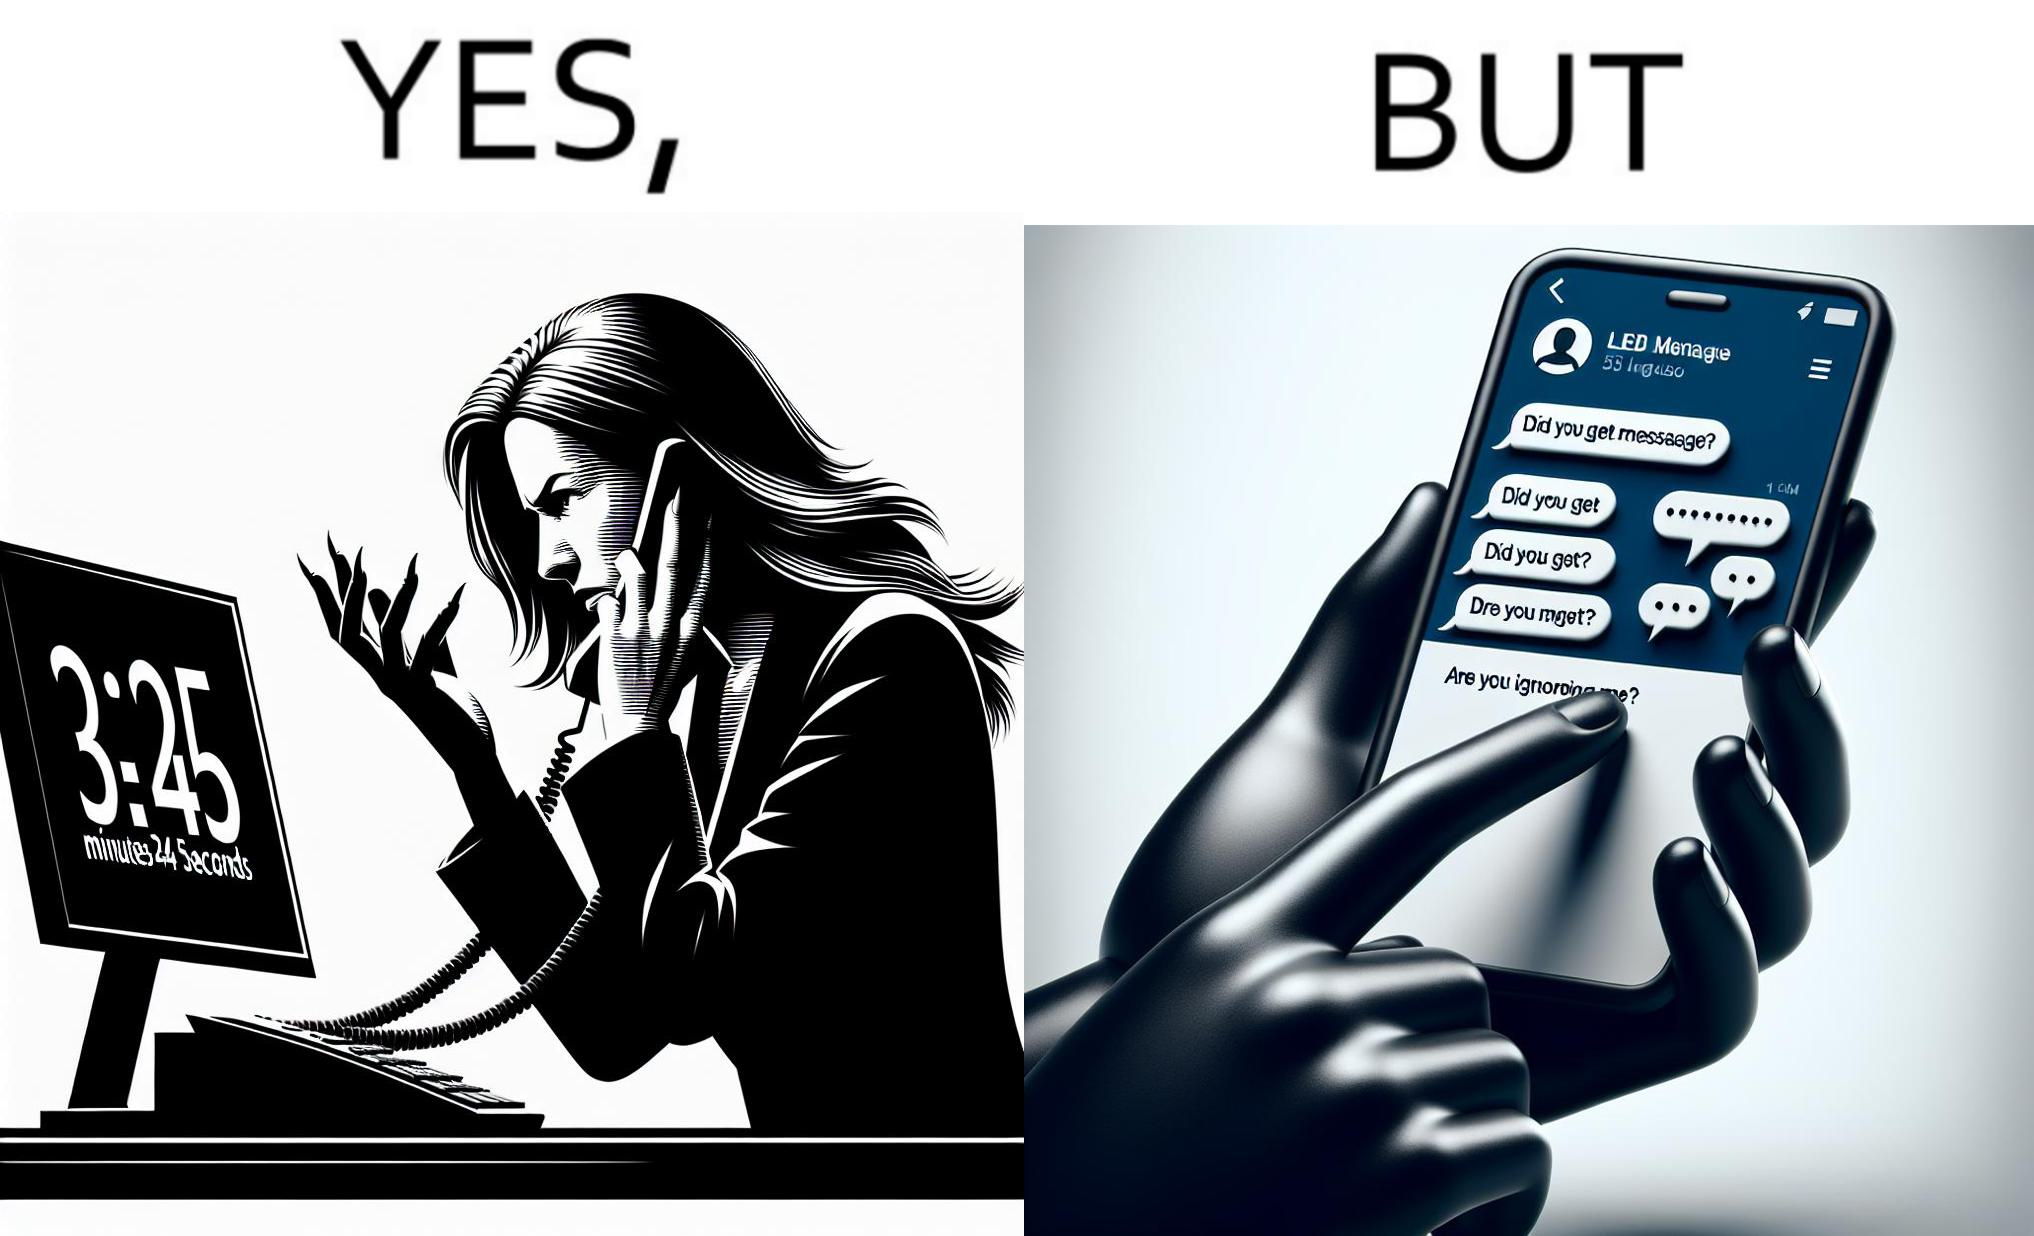What does this image depict? The image is ironical because while the woman is annoyed by the unresponsiveness of the call center, she herself is being unresponsive to many people in the chat. 